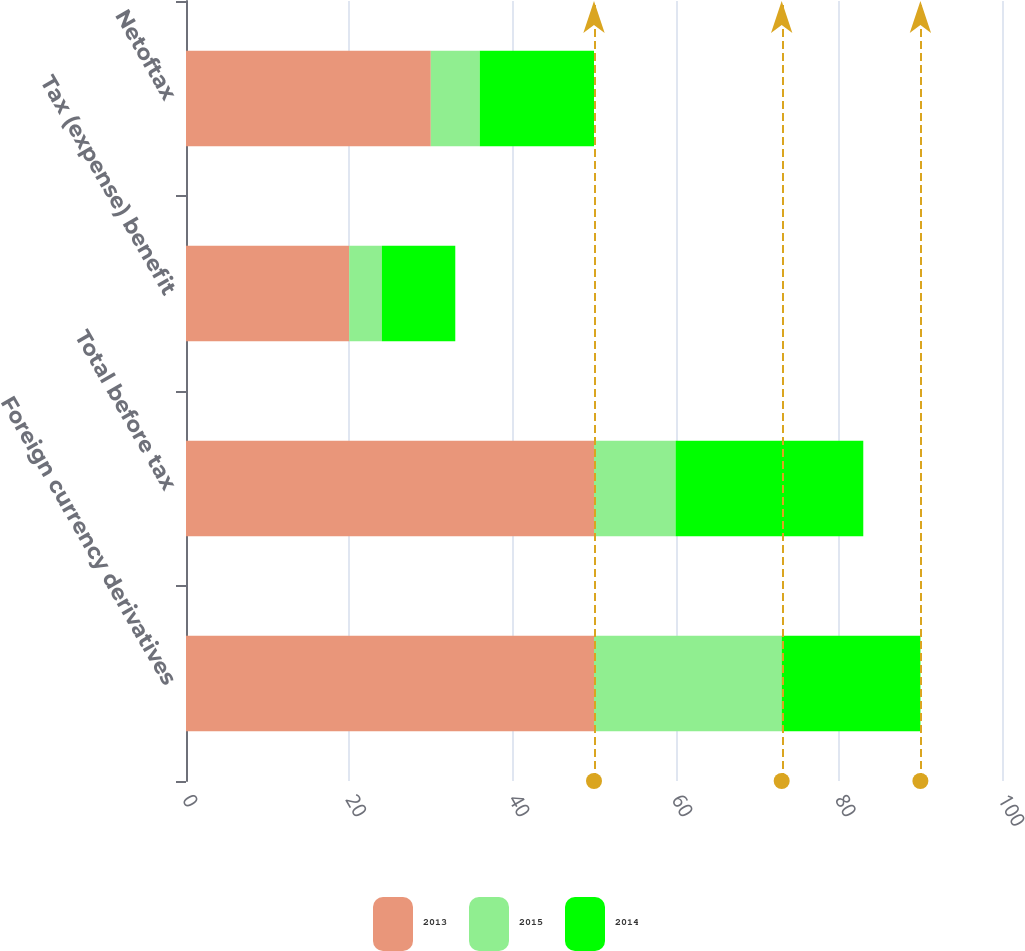Convert chart to OTSL. <chart><loc_0><loc_0><loc_500><loc_500><stacked_bar_chart><ecel><fcel>Foreign currency derivatives<fcel>Total before tax<fcel>Tax (expense) benefit<fcel>Netoftax<nl><fcel>2013<fcel>50<fcel>50<fcel>20<fcel>30<nl><fcel>2015<fcel>23<fcel>10<fcel>4<fcel>6<nl><fcel>2014<fcel>17<fcel>23<fcel>9<fcel>14<nl></chart> 